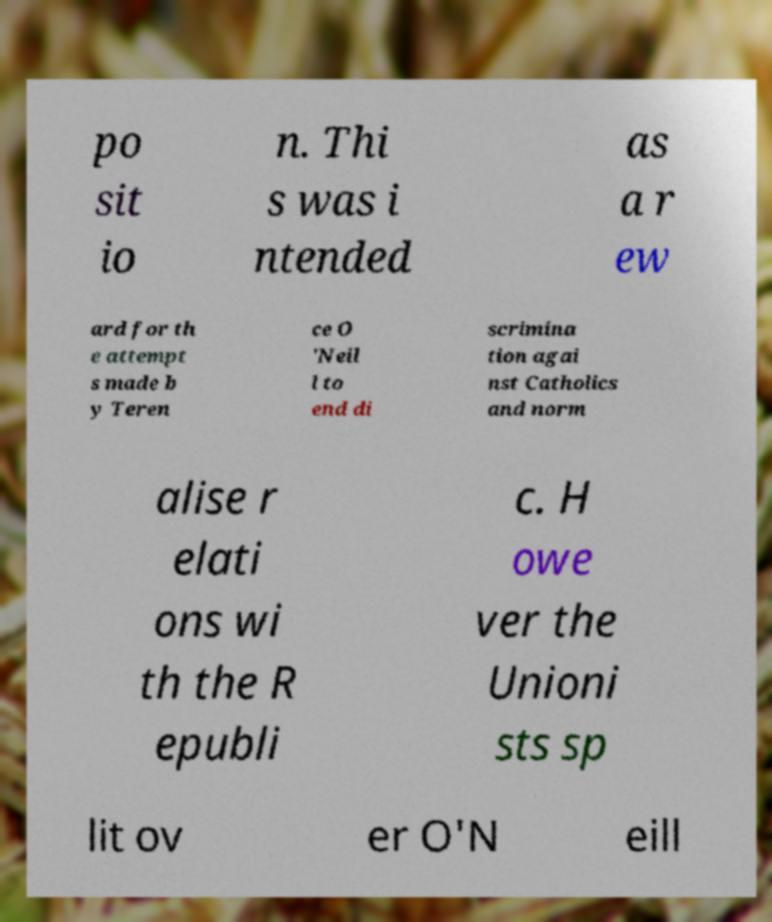Could you extract and type out the text from this image? po sit io n. Thi s was i ntended as a r ew ard for th e attempt s made b y Teren ce O 'Neil l to end di scrimina tion agai nst Catholics and norm alise r elati ons wi th the R epubli c. H owe ver the Unioni sts sp lit ov er O'N eill 